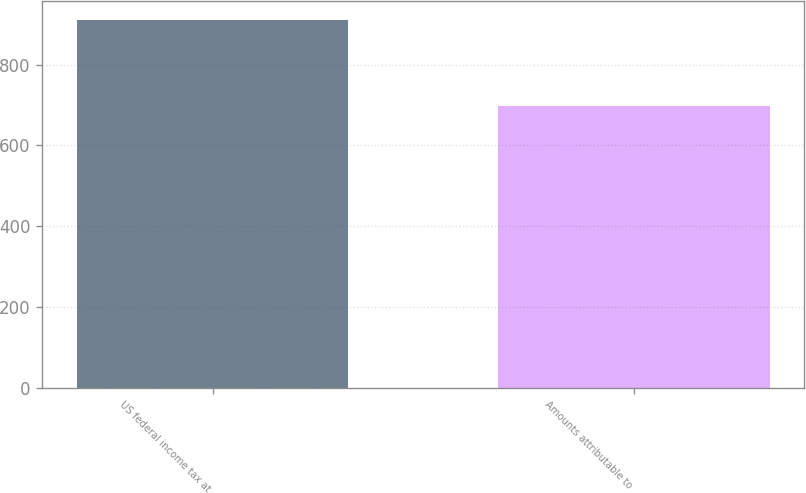Convert chart to OTSL. <chart><loc_0><loc_0><loc_500><loc_500><bar_chart><fcel>US federal income tax at<fcel>Amounts attributable to<nl><fcel>911<fcel>698<nl></chart> 